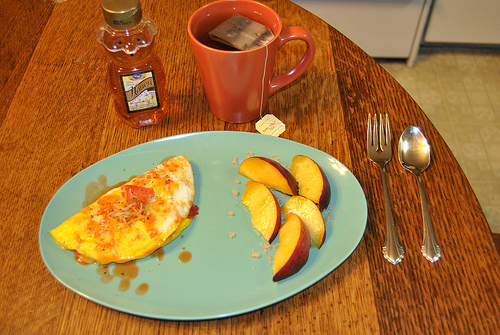<image>
Is there a honey in front of the cup? No. The honey is not in front of the cup. The spatial positioning shows a different relationship between these objects. 